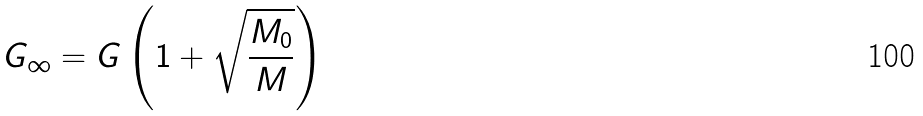Convert formula to latex. <formula><loc_0><loc_0><loc_500><loc_500>G _ { \infty } = G \left ( 1 + \sqrt { \frac { M _ { 0 } } { M } } \right )</formula> 